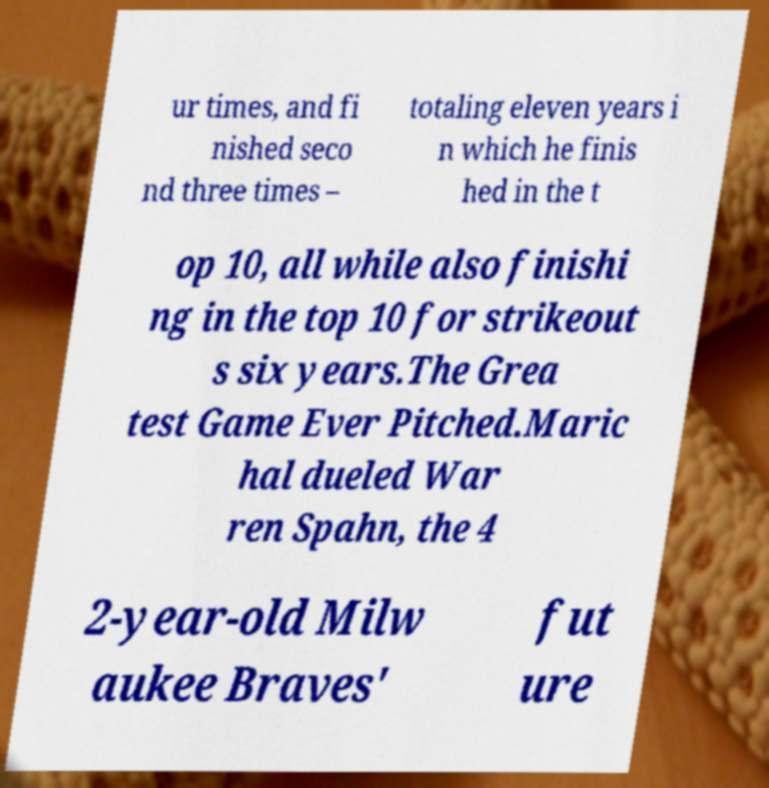Could you extract and type out the text from this image? ur times, and fi nished seco nd three times – totaling eleven years i n which he finis hed in the t op 10, all while also finishi ng in the top 10 for strikeout s six years.The Grea test Game Ever Pitched.Maric hal dueled War ren Spahn, the 4 2-year-old Milw aukee Braves' fut ure 